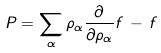Convert formula to latex. <formula><loc_0><loc_0><loc_500><loc_500>P = \sum _ { \alpha } \rho _ { \alpha } \frac { \partial } { \partial \rho _ { \alpha } } f \, - \, f</formula> 